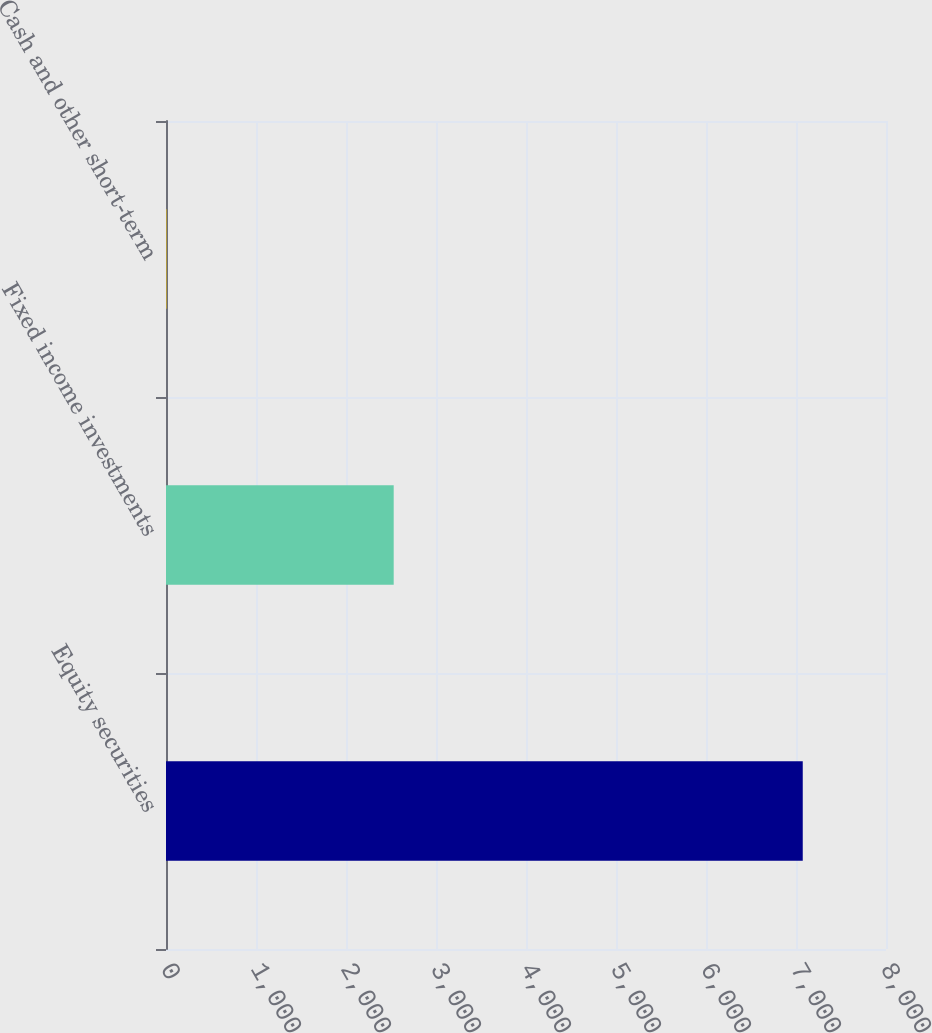Convert chart to OTSL. <chart><loc_0><loc_0><loc_500><loc_500><bar_chart><fcel>Equity securities<fcel>Fixed income investments<fcel>Cash and other short-term<nl><fcel>7075<fcel>2530<fcel>5<nl></chart> 